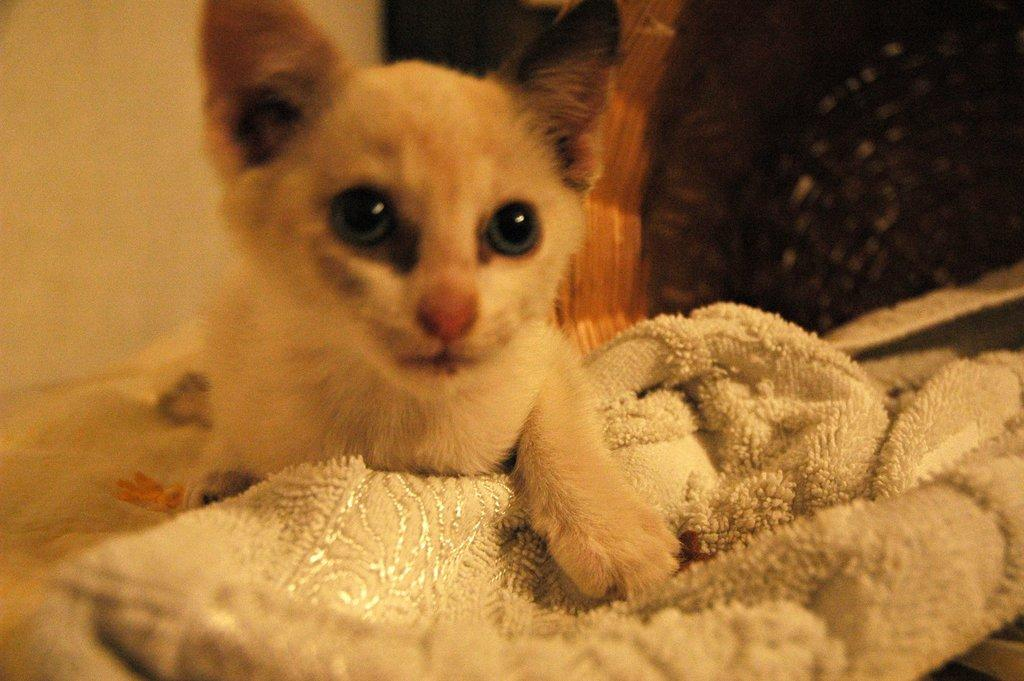What is the main subject in the center of the image? There is a cat in the center of the image. What is located at the bottom of the image? There is a towel at the bottom of the image. Can you describe the background of the image? There is an object and a wall in the background of the image. Is it snowing in the image? No, there is no indication of snow in the image. 